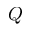<formula> <loc_0><loc_0><loc_500><loc_500>Q</formula> 